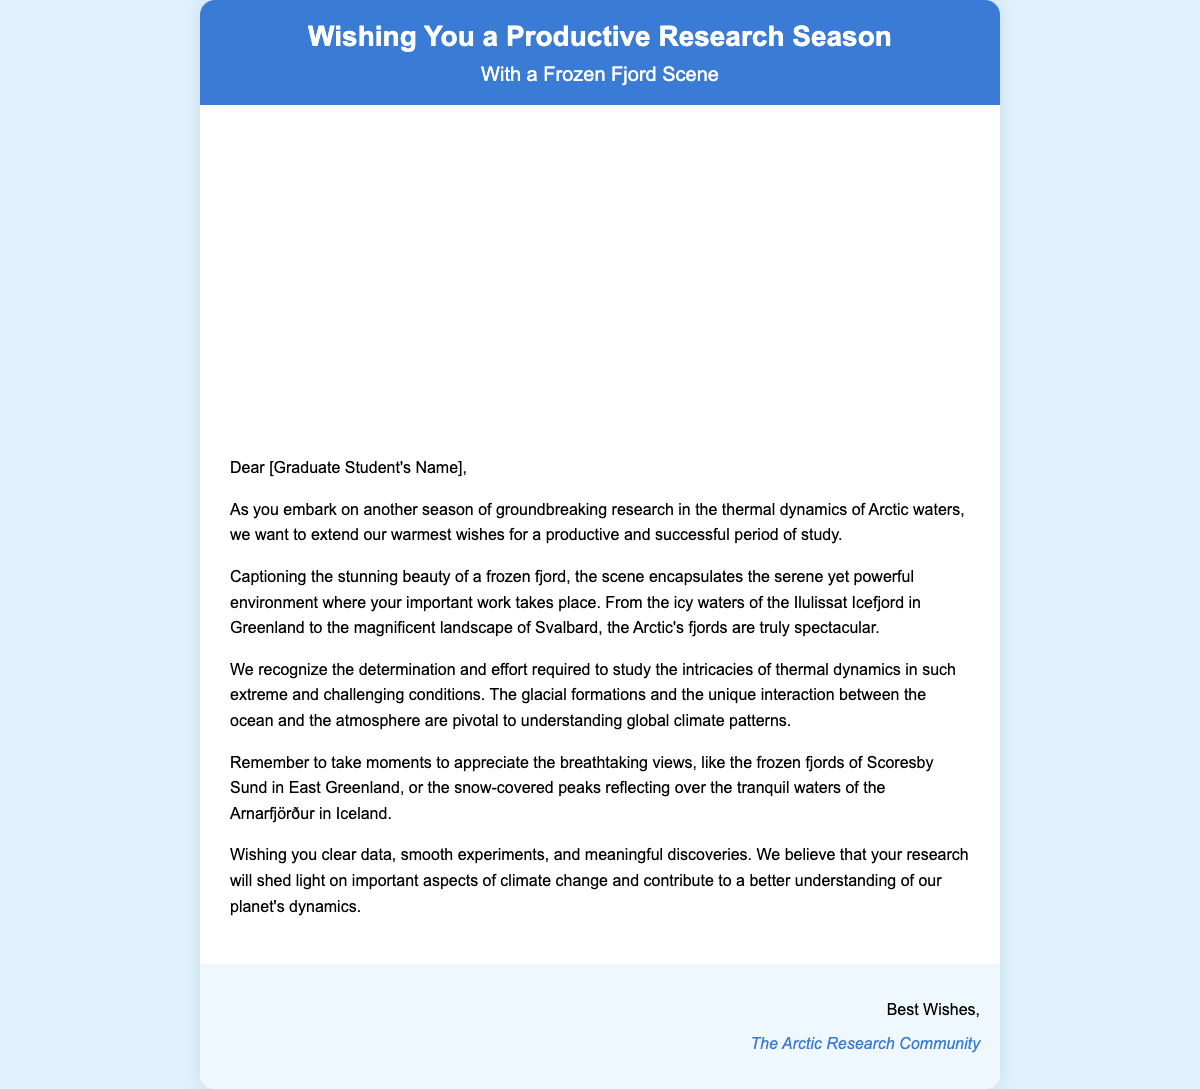What is the title of the greeting card? The title of the greeting card is presented in the card header, which states "Wishing You a Productive Research Season."
Answer: Wishing You a Productive Research Season What image is used in the greeting card? The card contains a background image representing a scenic view of a frozen fjord, referenced in the card body.
Answer: frozen fjord Who is the greeting card addressed to? The card is directed to a specific recipient, indicated by the placeholder "[Graduate Student's Name]."
Answer: [Graduate Student's Name] What is the main focus of the research mentioned in the card? The card speaks about studying the "thermal dynamics of Arctic waters," which defines the research intent.
Answer: thermal dynamics of Arctic waters Which fjord is highlighted as a remarkable location in the card? The card mentions "Ilulissat Icefjord in Greenland" as an example of a noteworthy research location in the Arctic.
Answer: Ilulissat Icefjord What wishes are expressed for the recipient's research activities? The card expresses a desire for "clear data, smooth experiments, and meaningful discoveries" for the recipient's research endeavors.
Answer: clear data, smooth experiments, and meaningful discoveries Who signed the greeting card? The signature at the bottom of the card states "The Arctic Research Community," indicating the sender.
Answer: The Arctic Research Community What does the card suggest to appreciate during research? The card encourages taking moments to appreciate "the breathtaking views," celebrating the beauty of the research environment.
Answer: breathtaking views 